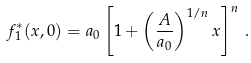<formula> <loc_0><loc_0><loc_500><loc_500>f _ { 1 } ^ { * } ( x , 0 ) = a _ { 0 } \left [ 1 + \left ( \frac { A } { a _ { 0 } } \right ) ^ { 1 / n } x \right ] ^ { n } \, .</formula> 